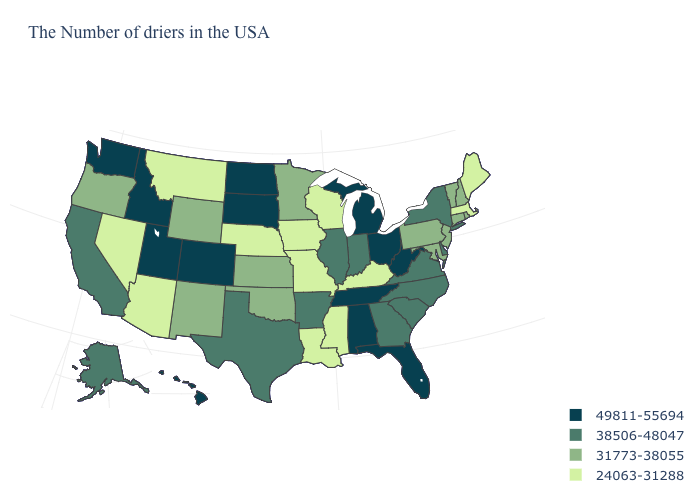Does Ohio have a lower value than Washington?
Write a very short answer. No. How many symbols are there in the legend?
Give a very brief answer. 4. What is the value of Kansas?
Be succinct. 31773-38055. What is the highest value in the South ?
Be succinct. 49811-55694. Name the states that have a value in the range 49811-55694?
Quick response, please. West Virginia, Ohio, Florida, Michigan, Alabama, Tennessee, South Dakota, North Dakota, Colorado, Utah, Idaho, Washington, Hawaii. Among the states that border North Carolina , does Tennessee have the lowest value?
Write a very short answer. No. What is the highest value in the USA?
Quick response, please. 49811-55694. What is the value of Arizona?
Short answer required. 24063-31288. Name the states that have a value in the range 31773-38055?
Concise answer only. Rhode Island, New Hampshire, Vermont, Connecticut, New Jersey, Maryland, Pennsylvania, Minnesota, Kansas, Oklahoma, Wyoming, New Mexico, Oregon. What is the lowest value in the USA?
Be succinct. 24063-31288. Does Colorado have a higher value than New York?
Answer briefly. Yes. What is the highest value in states that border New Hampshire?
Write a very short answer. 31773-38055. Name the states that have a value in the range 49811-55694?
Be succinct. West Virginia, Ohio, Florida, Michigan, Alabama, Tennessee, South Dakota, North Dakota, Colorado, Utah, Idaho, Washington, Hawaii. Does North Dakota have the same value as Utah?
Short answer required. Yes. Name the states that have a value in the range 31773-38055?
Write a very short answer. Rhode Island, New Hampshire, Vermont, Connecticut, New Jersey, Maryland, Pennsylvania, Minnesota, Kansas, Oklahoma, Wyoming, New Mexico, Oregon. 